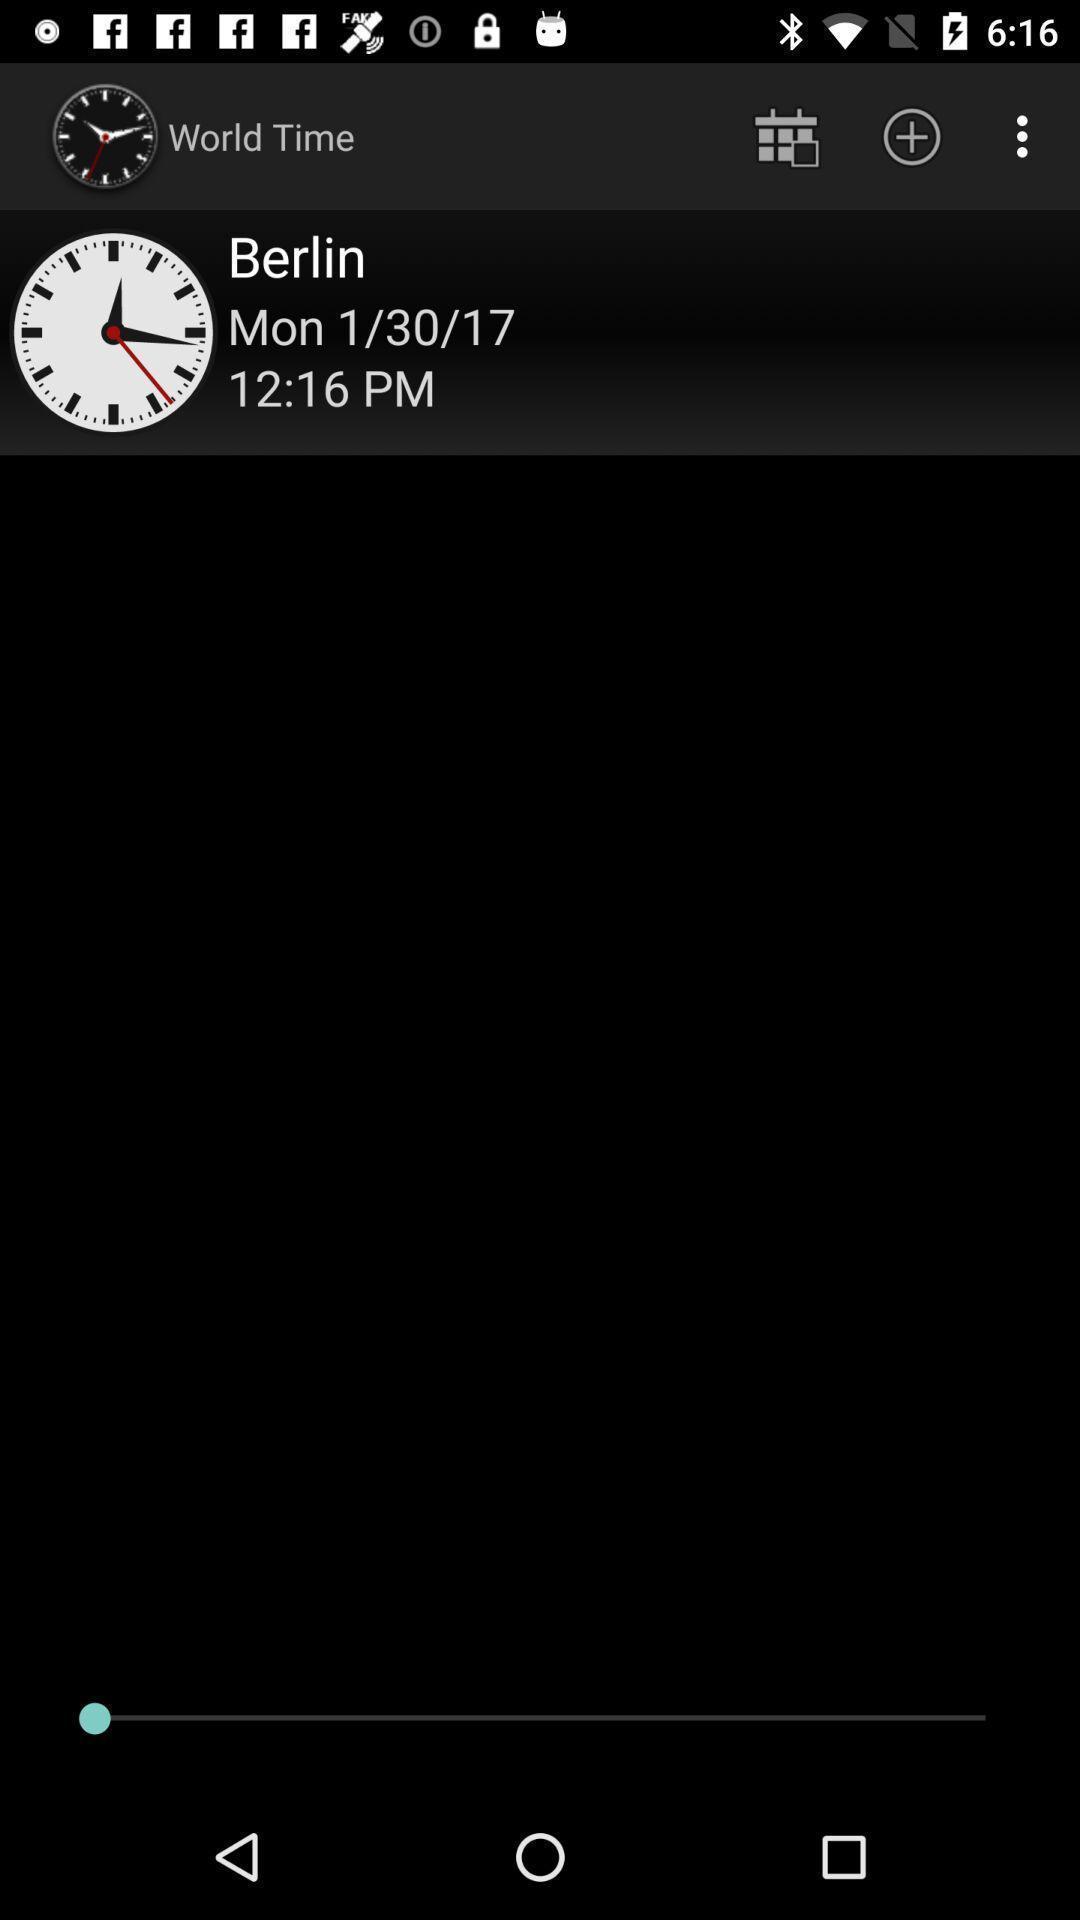Summarize the information in this screenshot. Showing the world time of particular location. 